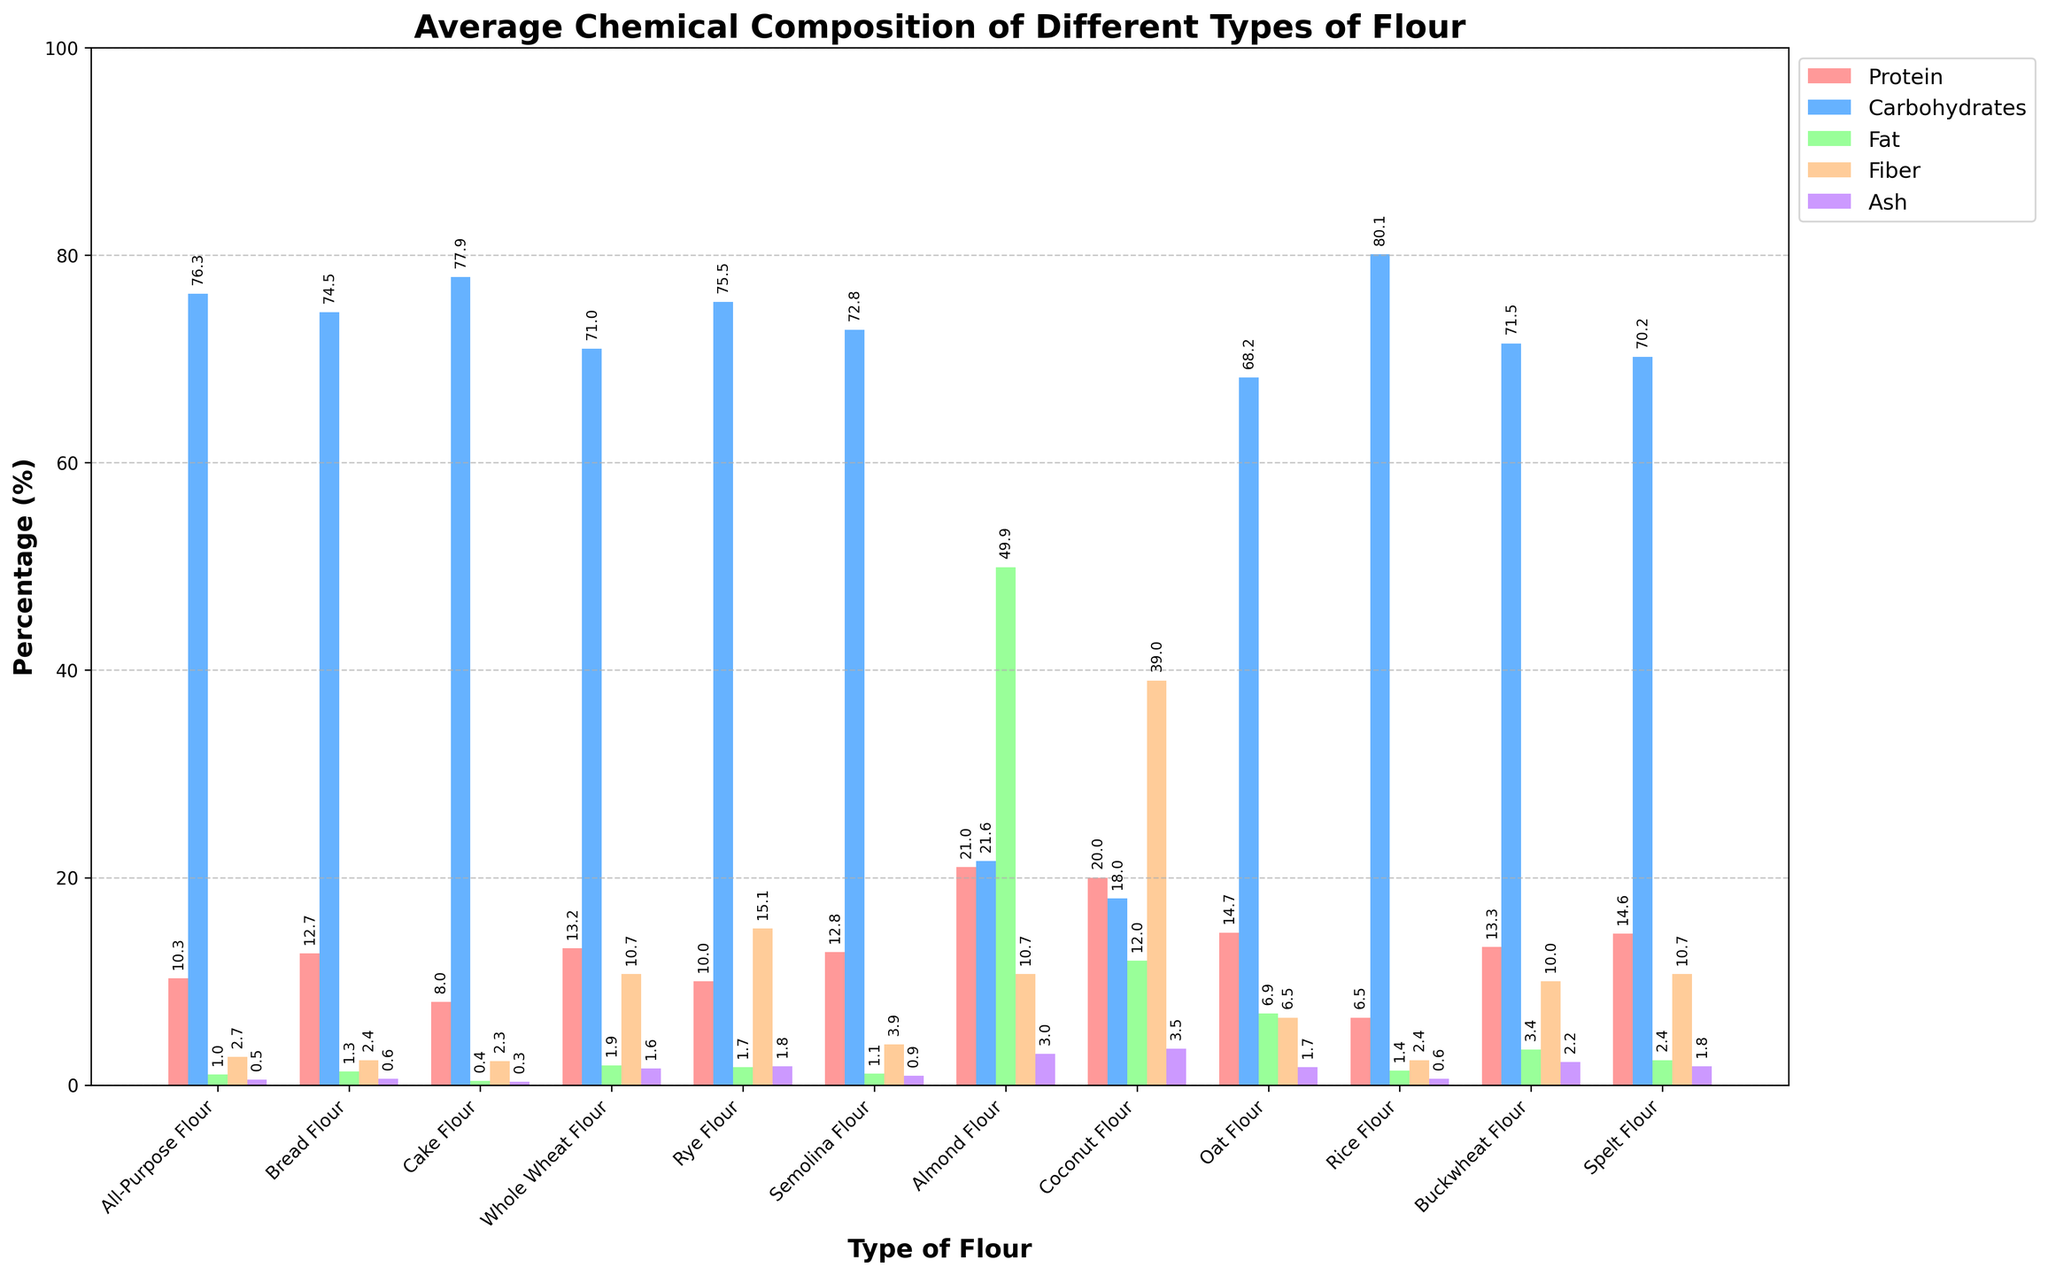Which type of flour has the highest protein content? The bar representing the protein content that reaches the highest value is for Almond Flour, which rises to 21%.
Answer: Almond Flour Which flour type has the lowest carbohydrate content? The bar for carbohydrate percentage that reaches the lowest value is Coconut Flour, standing at 18%.
Answer: Coconut Flour Which flour contains more fiber: Rye Flour or Oat Flour? By comparing the heights of the fiber bars for Rye Flour and Oat Flour, it's clear that Rye Flour has a higher fiber percentage at 15.1%, compared to 6.5% for Oat Flour.
Answer: Rye Flour Which type of flour has the highest ash content? The highest reaching bar in the ash category belongs to Coconut Flour, which stands at 3.5%.
Answer: Coconut Flour Is the fat content higher in Rice Flour or Semolina Flour? The fat bar for both types of flour needs to be compared, and it shows that Rice Flour has 1.4%, whereas Semolina Flour has 1.1%, making Rice Flour's fat content slightly higher.
Answer: Rice Flour What is the average protein content of all the flour types? Sum the protein values and divide by the number of flour types: (10.3 + 12.7 + 8.0 + 13.2 + 10.0 + 12.8 + 21.0 + 20.0 + 14.7 + 6.5 + 13.3 + 14.6) / 12 = 13.05.
Answer: 13.05 Which flour type has a fiber content closest to 10%? By observing the fiber content bars, it is clear that Buckwheat Flour and Spelt Flour both have fiber percentages near to 10% (each showing exactly 10.7%).
Answer: Buckwheat Flour, Spelt Flour Compare the total ash content for All-Purpose Flour and Bread Flour. Which is higher and by how much? The ash contents for All-Purpose Flour and Bread Flour are 0.5% and 0.6% respectively. The difference in ash content is 0.6% - 0.5% = 0.1%, making Bread Flour higher by 0.1%.
Answer: Bread Flour, 0.1% In which type of flour is the sum of fiber and ash content the highest? Performing the addition: All-Purpose Flour (2.7+0.5=3.2), Bread Flour (2.4+0.6=3.0), Cake Flour (2.3+0.3=2.6), Whole Wheat Flour (10.7+1.6=12.3), Rye Flour (15.1+1.8=16.9), Semolina Flour (3.9+0.9=4.8), Almond Flour (10.7+3.0=13.7), Coconut Flour (39.0+3.5=42.5), Oat Flour (6.5+1.7=8.2), Rice Flour (2.4+0.6=3.0), Buckwheat Flour (10.0+2.2=12.2), Spelt Flour (10.7+1.8=12.5). Hence, Coconut Flour has the highest combined fiber and ash content at 42.5%.
Answer: Coconut Flour 